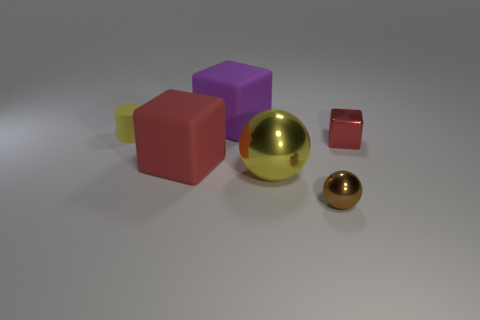What number of big objects are either shiny cubes or yellow metallic spheres?
Provide a short and direct response. 1. Does the tiny cylinder have the same color as the big shiny ball?
Make the answer very short. Yes. Are there more purple objects that are left of the red shiny thing than large red rubber cubes that are to the left of the tiny brown metal ball?
Offer a very short reply. No. Is the color of the small shiny thing in front of the yellow metal thing the same as the cylinder?
Your response must be concise. No. Are there any other things of the same color as the rubber cylinder?
Offer a terse response. Yes. Are there more big purple matte objects that are right of the brown metal ball than red matte cylinders?
Provide a short and direct response. No. Does the red metallic block have the same size as the yellow cylinder?
Give a very brief answer. Yes. There is another large red thing that is the same shape as the red metal thing; what is it made of?
Keep it short and to the point. Rubber. What number of cyan objects are either small matte cylinders or big spheres?
Ensure brevity in your answer.  0. There is a red block right of the big purple thing; what is its material?
Your answer should be compact. Metal. 